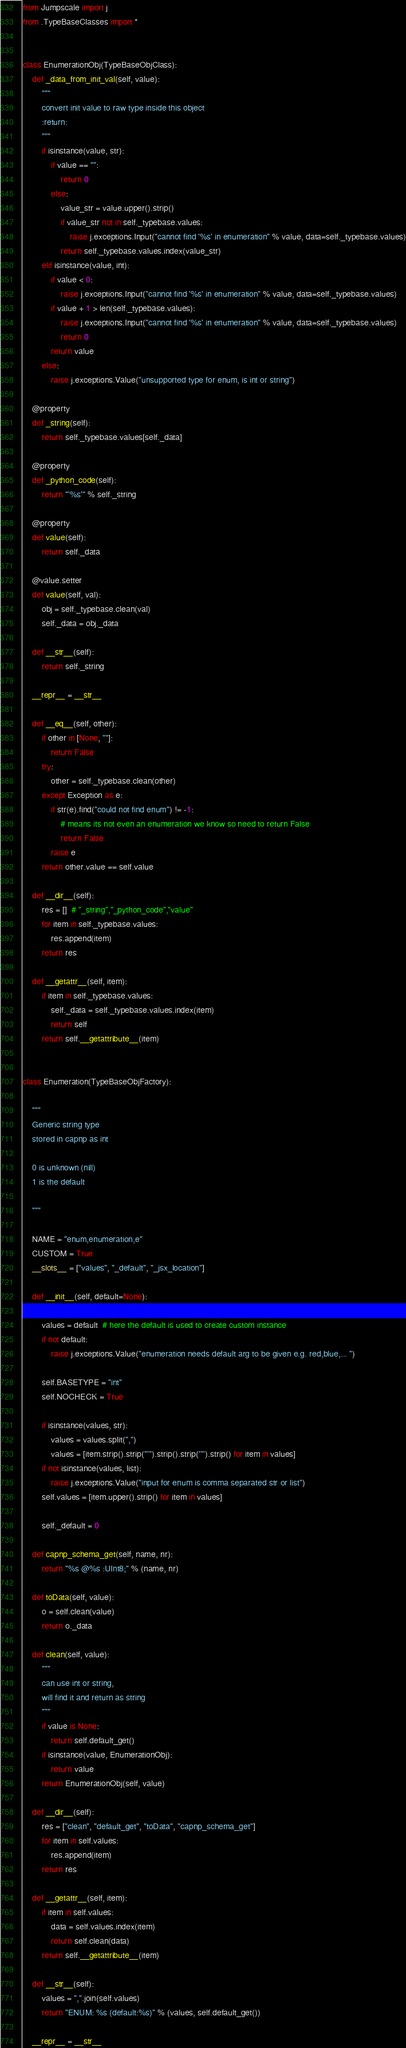Convert code to text. <code><loc_0><loc_0><loc_500><loc_500><_Python_>from Jumpscale import j
from .TypeBaseClasses import *


class EnumerationObj(TypeBaseObjClass):
    def _data_from_init_val(self, value):
        """
        convert init value to raw type inside this object
        :return:
        """
        if isinstance(value, str):
            if value == "":
                return 0
            else:
                value_str = value.upper().strip()
                if value_str not in self._typebase.values:
                    raise j.exceptions.Input("cannot find '%s' in enumeration" % value, data=self._typebase.values)
                return self._typebase.values.index(value_str)
        elif isinstance(value, int):
            if value < 0:
                raise j.exceptions.Input("cannot find '%s' in enumeration" % value, data=self._typebase.values)
            if value + 1 > len(self._typebase.values):
                raise j.exceptions.Input("cannot find '%s' in enumeration" % value, data=self._typebase.values)
                return 0
            return value
        else:
            raise j.exceptions.Value("unsupported type for enum, is int or string")

    @property
    def _string(self):
        return self._typebase.values[self._data]

    @property
    def _python_code(self):
        return "'%s'" % self._string

    @property
    def value(self):
        return self._data

    @value.setter
    def value(self, val):
        obj = self._typebase.clean(val)
        self._data = obj._data

    def __str__(self):
        return self._string

    __repr__ = __str__

    def __eq__(self, other):
        if other in [None, ""]:
            return False
        try:
            other = self._typebase.clean(other)
        except Exception as e:
            if str(e).find("could not find enum") != -1:
                # means its not even an enumeration we know so need to return False
                return False
            raise e
        return other.value == self.value

    def __dir__(self):
        res = []  # "_string","_python_code","value"
        for item in self._typebase.values:
            res.append(item)
        return res

    def __getattr__(self, item):
        if item in self._typebase.values:
            self._data = self._typebase.values.index(item)
            return self
        return self.__getattribute__(item)


class Enumeration(TypeBaseObjFactory):

    """
    Generic string type
    stored in capnp as int

    0 is unknown (nill)
    1 is the default

    """

    NAME = "enum,enumeration,e"
    CUSTOM = True
    __slots__ = ["values", "_default", "_jsx_location"]

    def __init__(self, default=None):

        values = default  # here the default is used to create custom instance
        if not default:
            raise j.exceptions.Value("enumeration needs default arg to be given e.g. red,blue,... ")

        self.BASETYPE = "int"
        self.NOCHECK = True

        if isinstance(values, str):
            values = values.split(",")
            values = [item.strip().strip("'").strip().strip('"').strip() for item in values]
        if not isinstance(values, list):
            raise j.exceptions.Value("input for enum is comma separated str or list")
        self.values = [item.upper().strip() for item in values]

        self._default = 0

    def capnp_schema_get(self, name, nr):
        return "%s @%s :UInt8;" % (name, nr)

    def toData(self, value):
        o = self.clean(value)
        return o._data

    def clean(self, value):
        """
        can use int or string,
        will find it and return as string
        """
        if value is None:
            return self.default_get()
        if isinstance(value, EnumerationObj):
            return value
        return EnumerationObj(self, value)

    def __dir__(self):
        res = ["clean", "default_get", "toData", "capnp_schema_get"]
        for item in self.values:
            res.append(item)
        return res

    def __getattr__(self, item):
        if item in self.values:
            data = self.values.index(item)
            return self.clean(data)
        return self.__getattribute__(item)

    def __str__(self):
        values = ",".join(self.values)
        return "ENUM: %s (default:%s)" % (values, self.default_get())

    __repr__ = __str__
</code> 